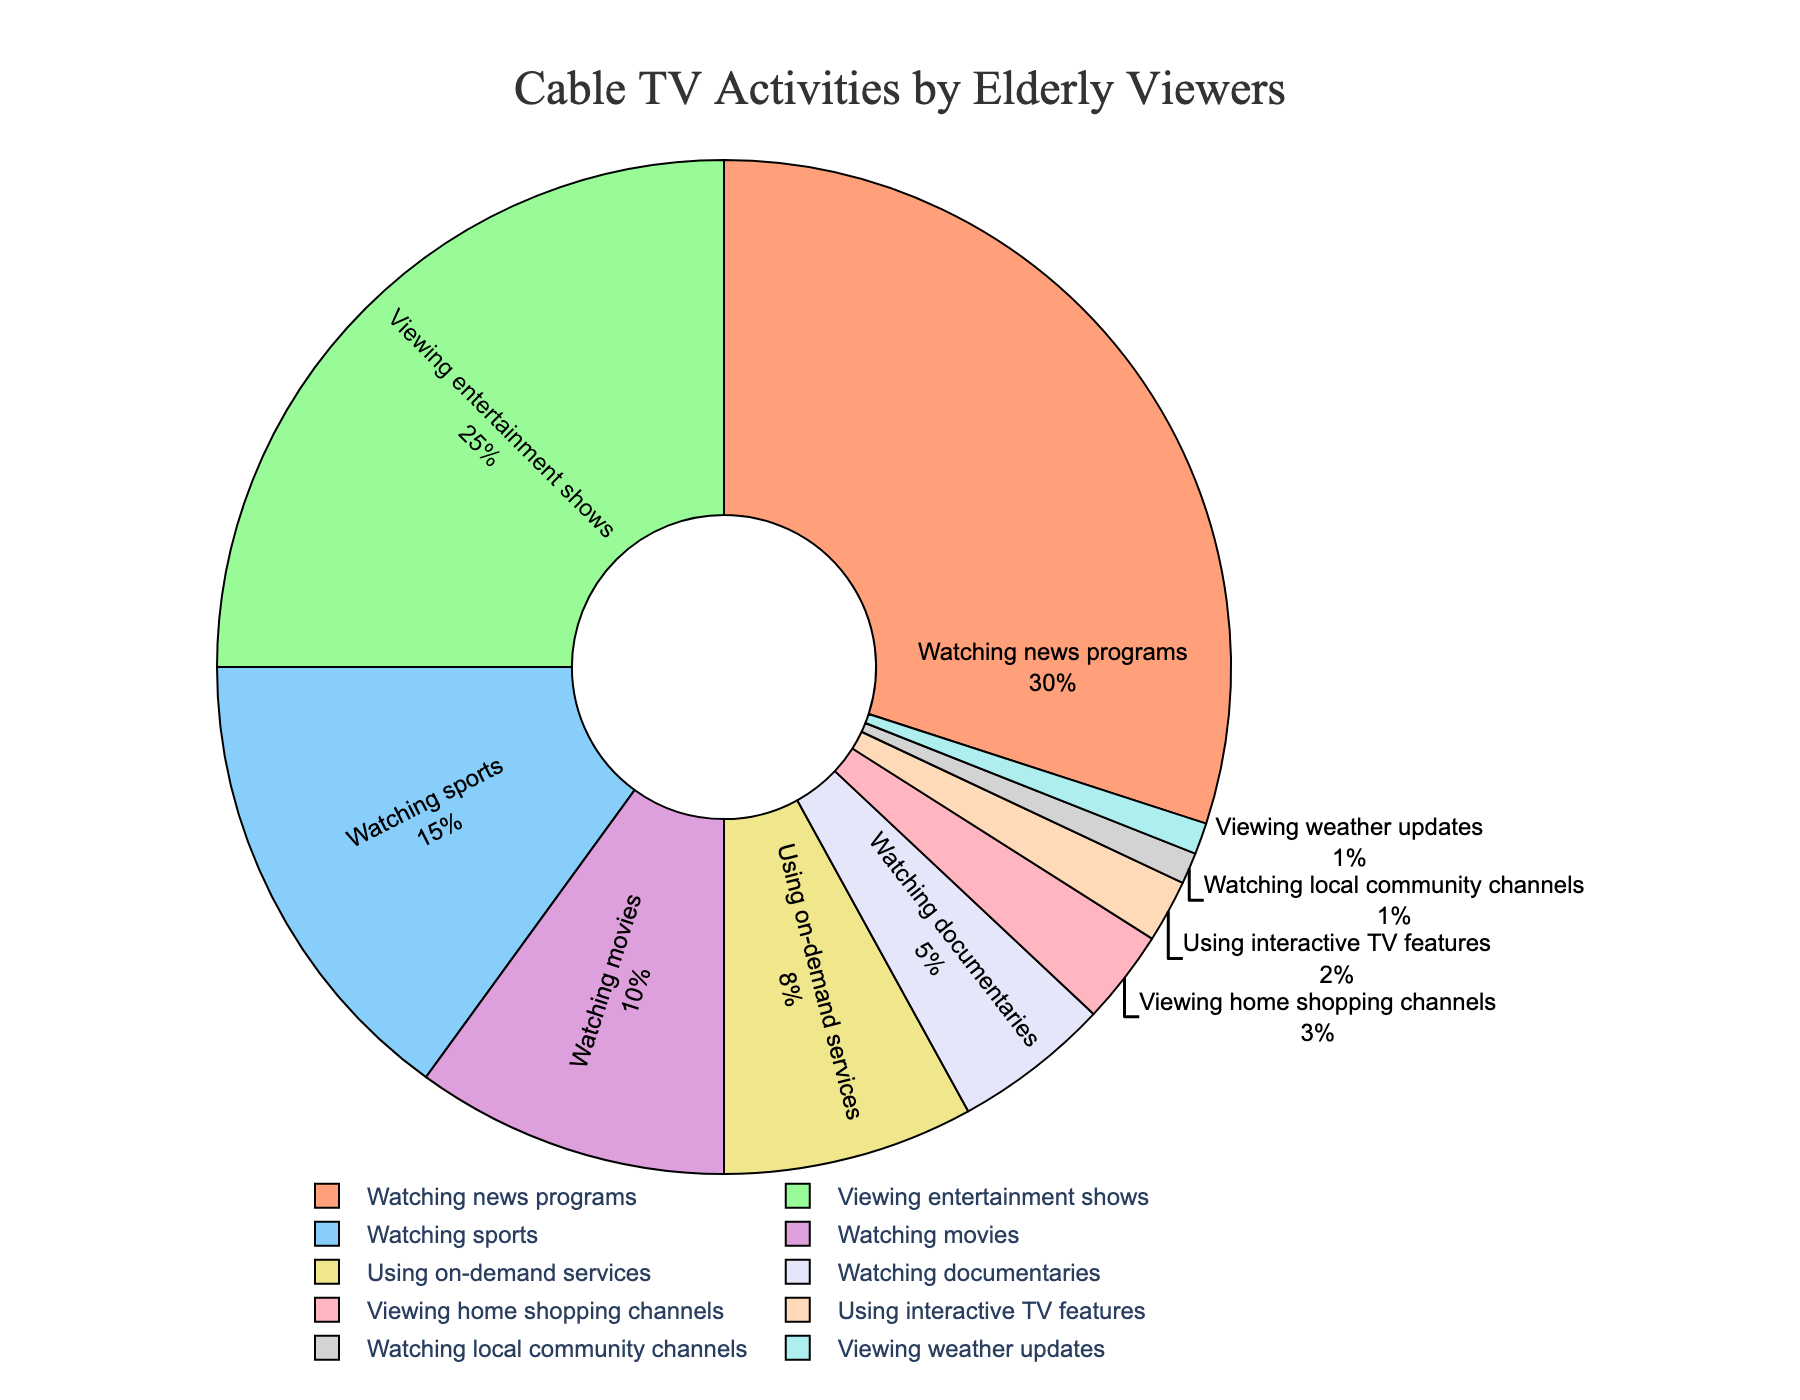What activity do elderly viewers spend the most time on? The pie chart shows that the biggest slice corresponds to "Watching news programs," which is labeled with the highest percentage.
Answer: Watching news programs Which two activities are the least popular among elderly viewers, and what are their percentages? The two smallest slices in the pie chart represent "Watching local community channels" and "Viewing weather updates", each labeled with a percentage of 1%.
Answer: Watching local community channels, Viewing weather updates (1% each) What is the combined percentage of time spent watching sports and watching movies? From the pie chart, the slice for "Watching sports" is labeled with 15%, and the slice for "Watching movies" is labeled with 10%. Adding these percentages together gives 15% + 10% = 25%.
Answer: 25% Which activity has a larger percentage: using on-demand services or viewing home shopping channels? By how much? The pie chart shows that the slice for "Using on-demand services" is labeled with 8%, while the slice for "Viewing home shopping channels" is labeled with 3%. The difference is 8% - 3% = 5%.
Answer: Using on-demand services by 5% What's the second most popular activity and its percentage? The pie chart indicates that the second largest slice is for "Viewing entertainment shows," labeled with 25%.
Answer: Viewing entertainment shows (25%) Which activities are represented using warm colors on the pie chart? The labels for warm colors can be identified visually: "Watching news programs" (peach), "Viewing entertainment shows" (light green), and "Watching sports" (light blue) are not warm colors, the primary warm color visible is "Using on-demand services" (light pink).
Answer: Using on-demand services (light pink) How much more popular is watching entertainment shows compared to using interactive TV features? The slice for "Viewing entertainment shows" is labeled with 25%, while "Using interactive TV features" is labeled with 2%. The difference is 25% - 2% = 23%.
Answer: 23% Are the percentages for watching documentaries and watching movies greater or smaller than the percentage for watching sports combined? The pie chart shows "Watching documentaries" at 5% and "Watching movies" at 10%, bringing the total to 5% + 10% = 15%. "Watching sports" alone is already 15%, so they are equal.
Answer: Equal What activities combined make up at least half of the total time spent on cable TV? From the pie chart, the largest segments are "Watching news programs" (30%) and "Viewing entertainment shows" (25%). Combined, they total 30% + 25% = 55%, which is more than half.
Answer: Watching news programs, Viewing entertainment shows 